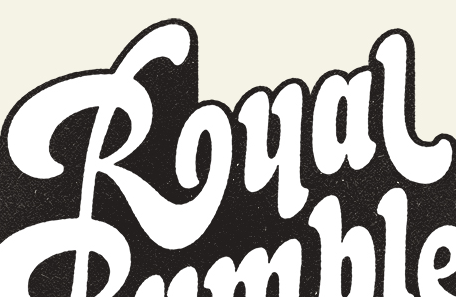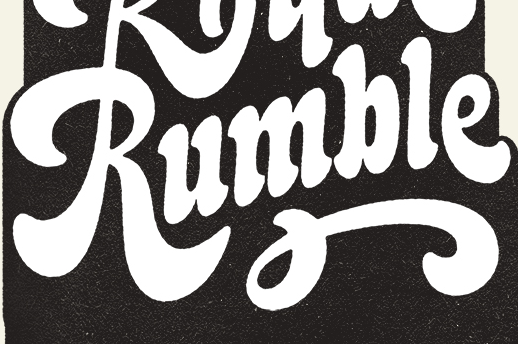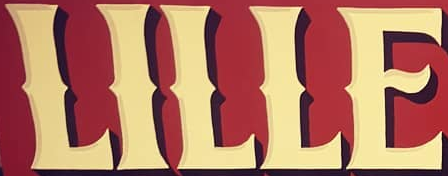Read the text from these images in sequence, separated by a semicolon. Rual; Rumble; LILLE 